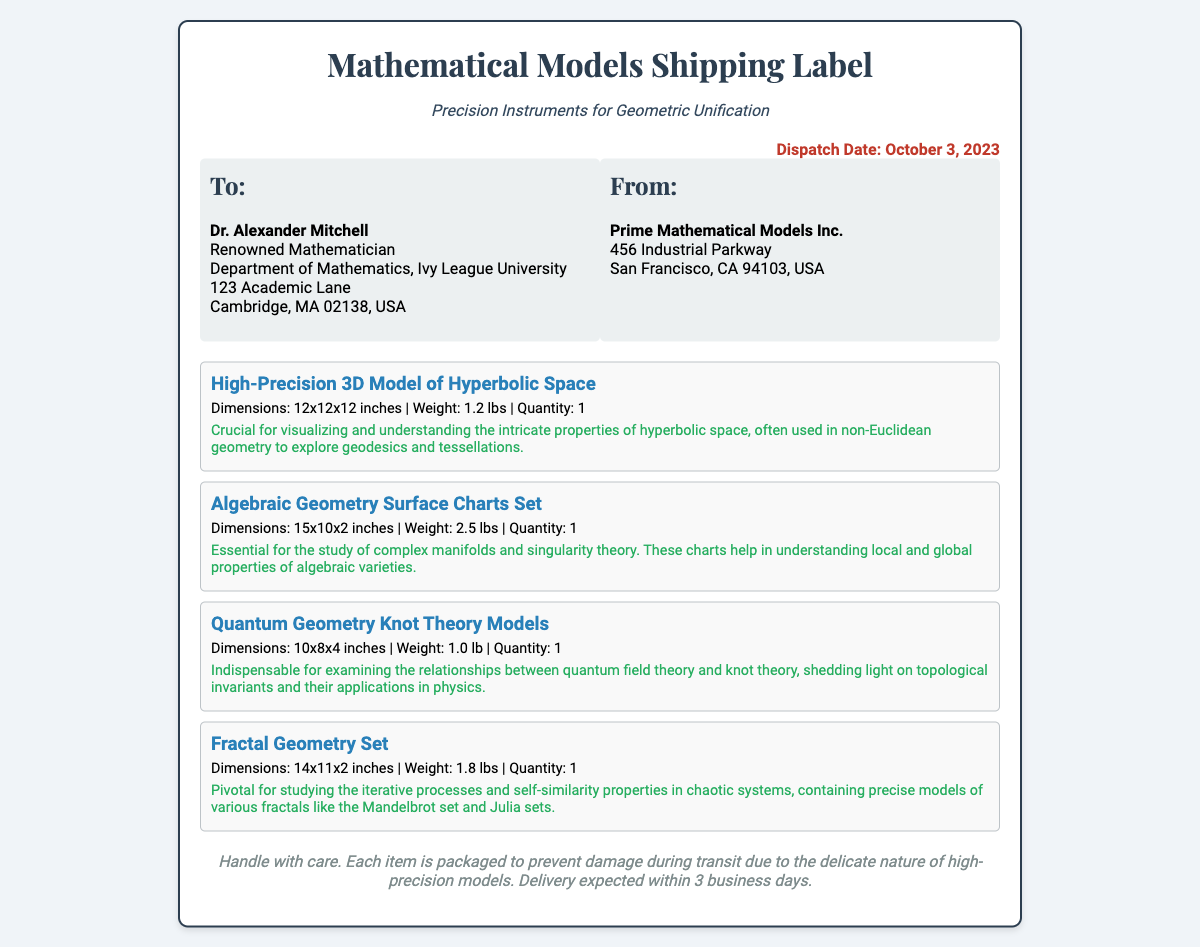What is the dispatch date? The dispatch date is explicitly stated in the document header.
Answer: October 3, 2023 Who is the recipient of the shipment? The recipient's name is listed in the "To:" section of the address.
Answer: Dr. Alexander Mitchell What is the weight of the Algebraic Geometry Surface Charts Set? The weight is provided in the description of the item.
Answer: 2.5 lbs How many items are included in the shipment? The number of different items can be counted from the list of items in the document.
Answer: 4 What is the significance of the High-Precision 3D Model of Hyperbolic Space? The document contains a description of the mathematical significance of this model.
Answer: Visualization of hyperbolic space What is the address of the sender? The sender's address is located in the "From:" section of the document.
Answer: 456 Industrial Parkway, San Francisco, CA 94103, USA Which item is crucial for examining relationships between quantum field theory and knot theory? This refers to a specific product mentioned in the items section.
Answer: Quantum Geometry Knot Theory Models What is the expected delivery time? The delivery expectation is noted as part of the handling instructions in the document.
Answer: Within 3 business days 